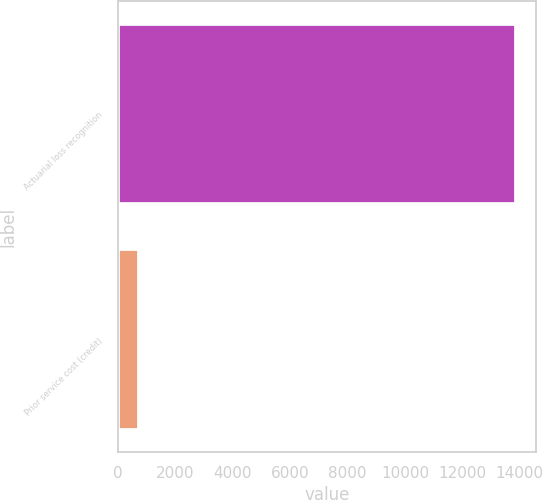Convert chart to OTSL. <chart><loc_0><loc_0><loc_500><loc_500><bar_chart><fcel>Actuarial loss recognition<fcel>Prior service cost (credit)<nl><fcel>13863<fcel>729<nl></chart> 